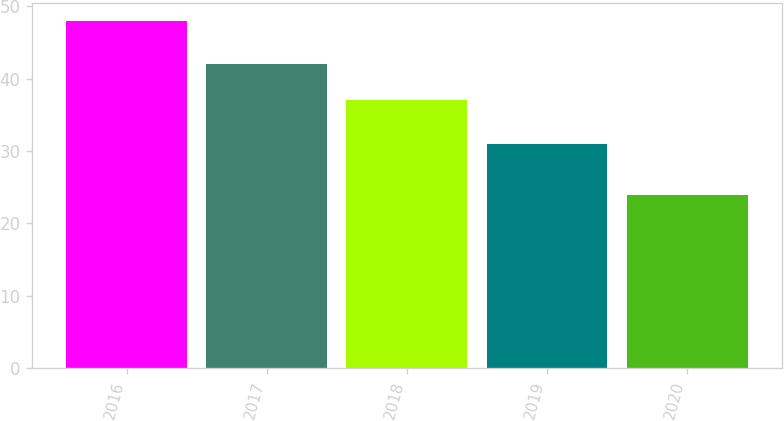Convert chart. <chart><loc_0><loc_0><loc_500><loc_500><bar_chart><fcel>2016<fcel>2017<fcel>2018<fcel>2019<fcel>2020<nl><fcel>48<fcel>42<fcel>37<fcel>31<fcel>24<nl></chart> 